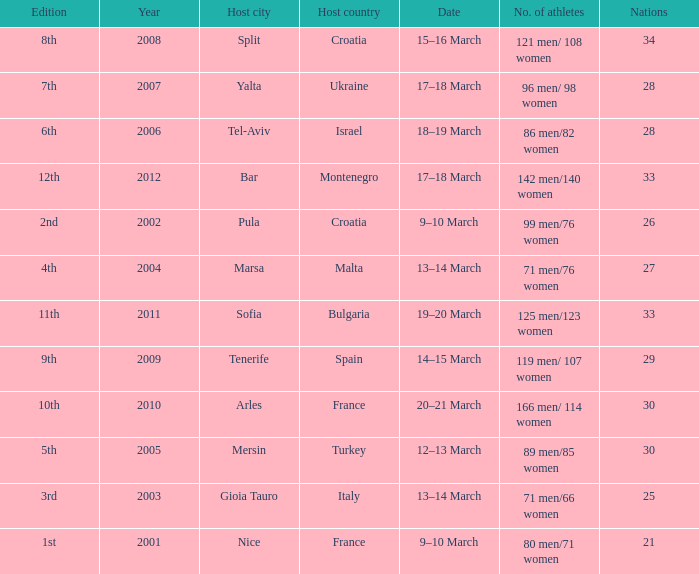Who was the host country when Bar was the host city? Montenegro. 